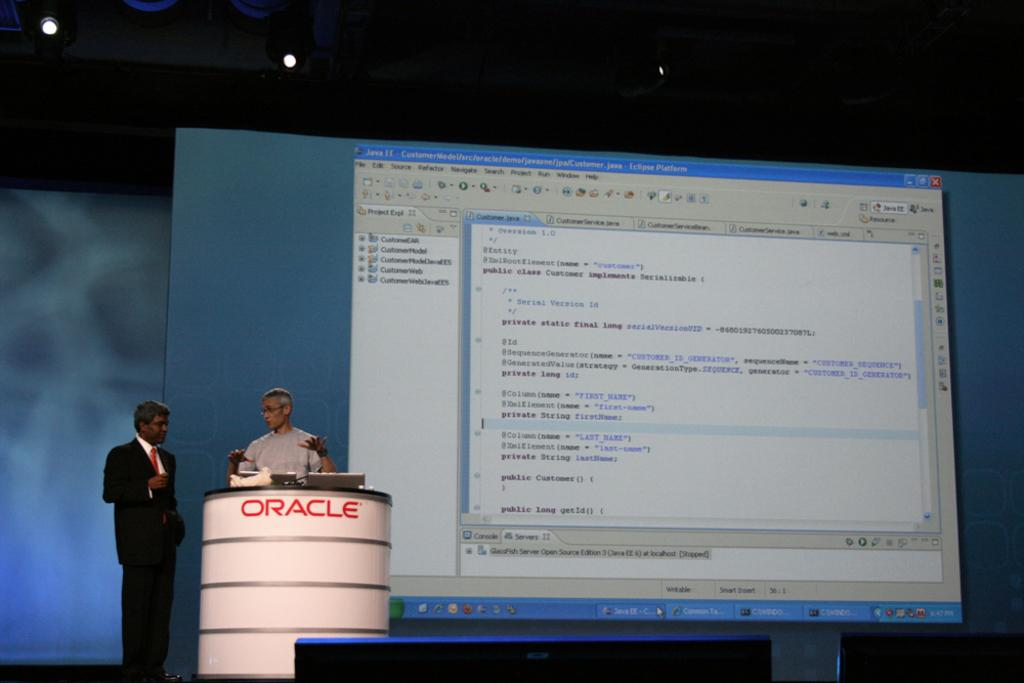<image>
Summarize the visual content of the image. Two men speak in a presentation near an Oracle podium. 